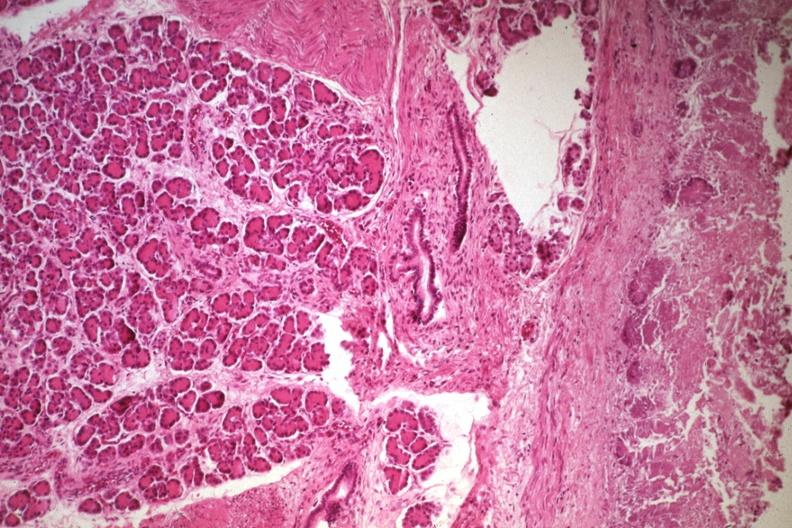what does this image show?
Answer the question using a single word or phrase. Not the best photo but a good illustration of lesion 